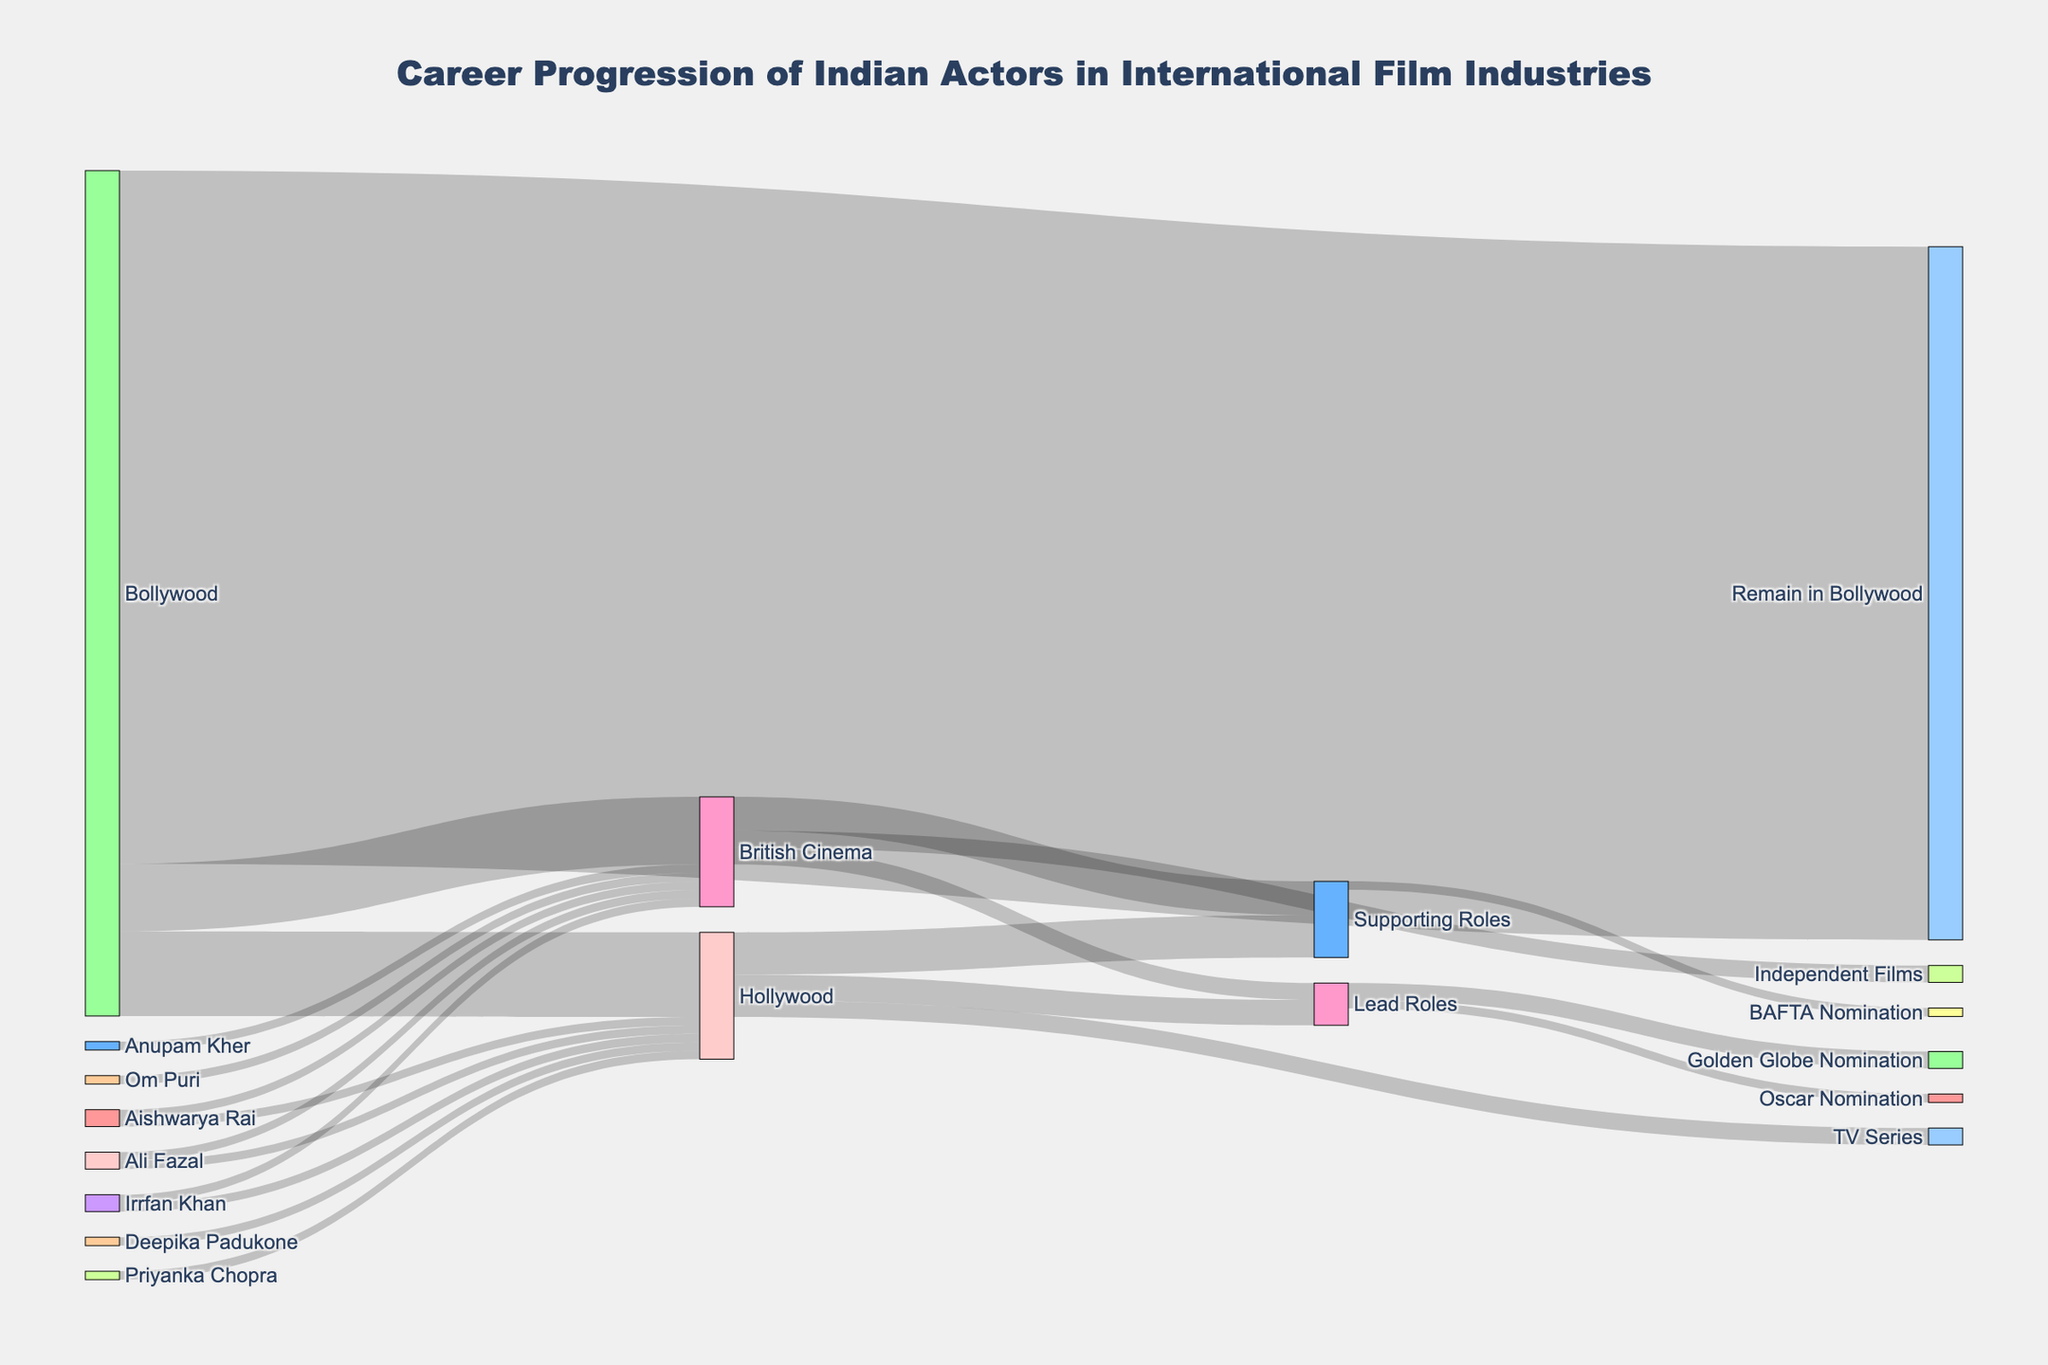How many actors moved from Bollywood to Hollywood? The diagram shows a link between Bollywood and Hollywood with a flow value. This value represents the number of actors who made the transition.
Answer: 10 Which transition has a higher value: Bollywood to Hollywood or Bollywood to British Cinema? Compare the flow values between the two transitions. The Bollywood to Hollywood transition has a value of 10, while Bollywood to British Cinema has a value of 8.
Answer: Bollywood to Hollywood How many actors remained in Bollywood? Refer to the flow value for the transition from Bollywood to Remain in Bollywood, which indicates the number of actors who stayed.
Answer: 82 Compare the number of actors taking lead roles in Hollywood vs British Cinema. Check the flow values for Lead Roles under both Hollywood and British Cinema. Hollywood has a value of 3, and British Cinema has a value of 2.
Answer: Hollywood How many actors received nominations for awards from lead roles in Hollywood? Look at the combined flow values for Oscar Nomination and Golden Globe Nomination under Lead Roles from Hollywood. Oscar Nomination has a value of 1 and Golden Globe Nomination has a value of 2. Summing these gives us the total number of nominations.
Answer: 3 What percentage of the total actors transitioned to Hollywood? The total number of actors transitioning from Bollywood is the sum of those moving to Hollywood, British Cinema, and those remaining in Bollywood (10 + 8 + 82). The percentage is calculated as (10 / 100) * 100%.
Answer: 10% Which actor appears in both Hollywood and British Cinema? Look at the list of actors and their transitions. Irrfan Khan is the only actor who has both Hollywood and British Cinema next to his name.
Answer: Irrfan Khan What is the total flow of actors into British Cinema? Add the total flow values from Bollywood to British Cinema (8) and individual actors transitioning directly to British Cinema (Irrfan Khan, Om Puri, Aishwarya Rai, Anupam Kher, and Ali Fazal each have 1). So, the total is 8 + 5.
Answer: 13 How many actors received any nominations from supporting roles? Check the values for award nominations under Supporting Roles. BAFTA Nomination has a value of 1, indicating the number of actors receiving nominations from supporting roles.
Answer: 1 Compare the number of flows from Bollywood to international cinema (Hollywood and British Cinema) against those who stayed in Bollywood. Calculate the sum of actors transitioning to Hollywood and British Cinema (10 + 8 = 18) and compare it with the number who remained in Bollywood (82).
Answer: Stayed in Bollywood 